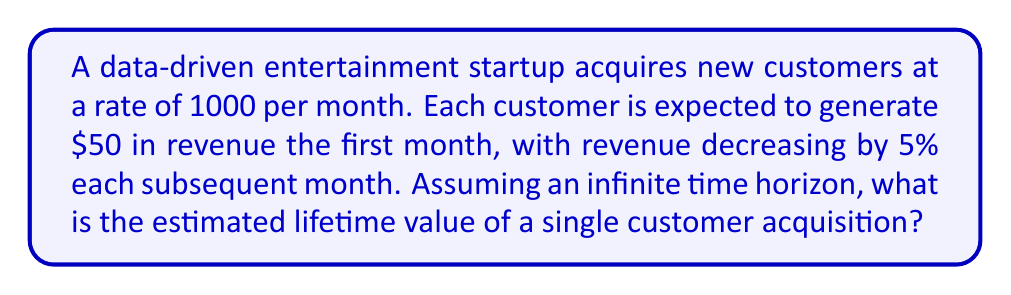Could you help me with this problem? Let's approach this step-by-step:

1) First, let's define our series. The revenue for each month can be represented as:

   Month 1: $50
   Month 2: $50 * 0.95
   Month 3: $50 * 0.95^2
   ...and so on.

2) This forms a geometric series with first term $a = 50$ and common ratio $r = 0.95$.

3) The sum of an infinite geometric series is given by the formula:

   $$ S_{\infty} = \frac{a}{1-r} $$

   Where $S_{\infty}$ is the sum of the infinite series, $a$ is the first term, and $r$ is the common ratio.

4) Substituting our values:

   $$ S_{\infty} = \frac{50}{1-0.95} = \frac{50}{0.05} $$

5) Calculating this:

   $$ S_{\infty} = 1000 $$

Therefore, the estimated lifetime value of a single customer acquisition is $1000.
Answer: $1000 